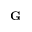<formula> <loc_0><loc_0><loc_500><loc_500>G</formula> 